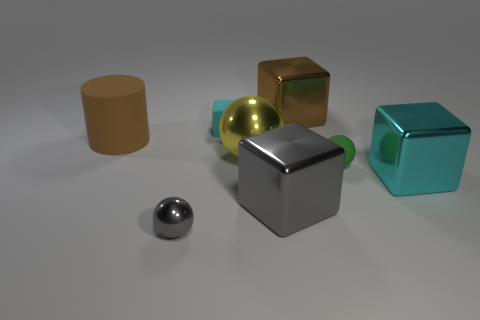There is a big block that is behind the large gray thing and left of the cyan shiny thing; what material is it made of?
Keep it short and to the point. Metal. What is the size of the gray sphere?
Make the answer very short. Small. Does the small rubber block have the same color as the big object behind the brown cylinder?
Your response must be concise. No. How many other objects are the same color as the cylinder?
Make the answer very short. 1. Do the block that is in front of the big cyan metal cube and the gray object left of the gray metallic block have the same size?
Give a very brief answer. No. What is the color of the tiny object behind the tiny green matte ball?
Your answer should be compact. Cyan. Is the number of gray things that are on the left side of the large brown cylinder less than the number of brown matte objects?
Ensure brevity in your answer.  Yes. Are the brown cylinder and the small gray thing made of the same material?
Your answer should be very brief. No. What size is the yellow metal thing that is the same shape as the green matte thing?
Your response must be concise. Large. How many things are either matte objects that are to the right of the small shiny thing or metal things behind the tiny gray object?
Provide a succinct answer. 6. 